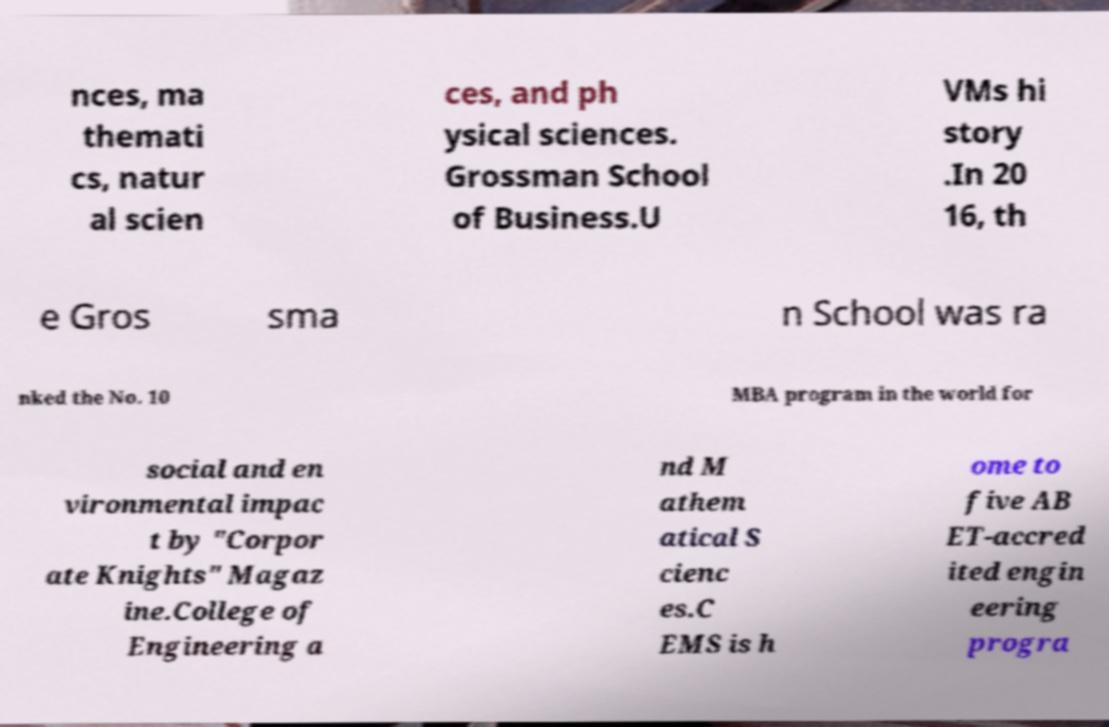There's text embedded in this image that I need extracted. Can you transcribe it verbatim? nces, ma themati cs, natur al scien ces, and ph ysical sciences. Grossman School of Business.U VMs hi story .In 20 16, th e Gros sma n School was ra nked the No. 10 MBA program in the world for social and en vironmental impac t by "Corpor ate Knights" Magaz ine.College of Engineering a nd M athem atical S cienc es.C EMS is h ome to five AB ET-accred ited engin eering progra 